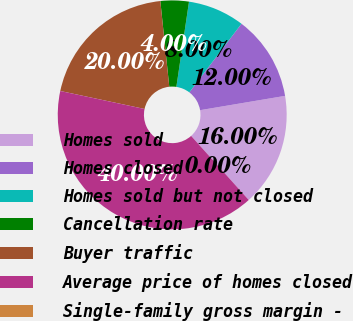Convert chart to OTSL. <chart><loc_0><loc_0><loc_500><loc_500><pie_chart><fcel>Homes sold<fcel>Homes closed<fcel>Homes sold but not closed<fcel>Cancellation rate<fcel>Buyer traffic<fcel>Average price of homes closed<fcel>Single-family gross margin -<nl><fcel>16.0%<fcel>12.0%<fcel>8.0%<fcel>4.0%<fcel>20.0%<fcel>40.0%<fcel>0.0%<nl></chart> 